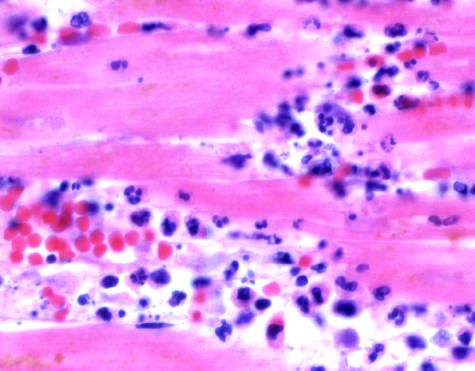do apoptotic cells in colonic epithelium show an inflammatory reaction in the myocardium after ischemic necrosis infarction?
Answer the question using a single word or phrase. No 